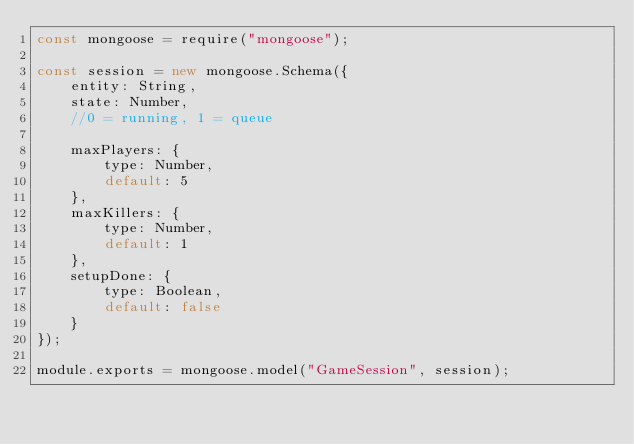Convert code to text. <code><loc_0><loc_0><loc_500><loc_500><_JavaScript_>const mongoose = require("mongoose");

const session = new mongoose.Schema({
    entity: String,
    state: Number,
    //0 = running, 1 = queue

    maxPlayers: {
        type: Number,
        default: 5
    },
    maxKillers: {
        type: Number,
        default: 1
    },
    setupDone: {
        type: Boolean,
        default: false
    }
});

module.exports = mongoose.model("GameSession", session);</code> 